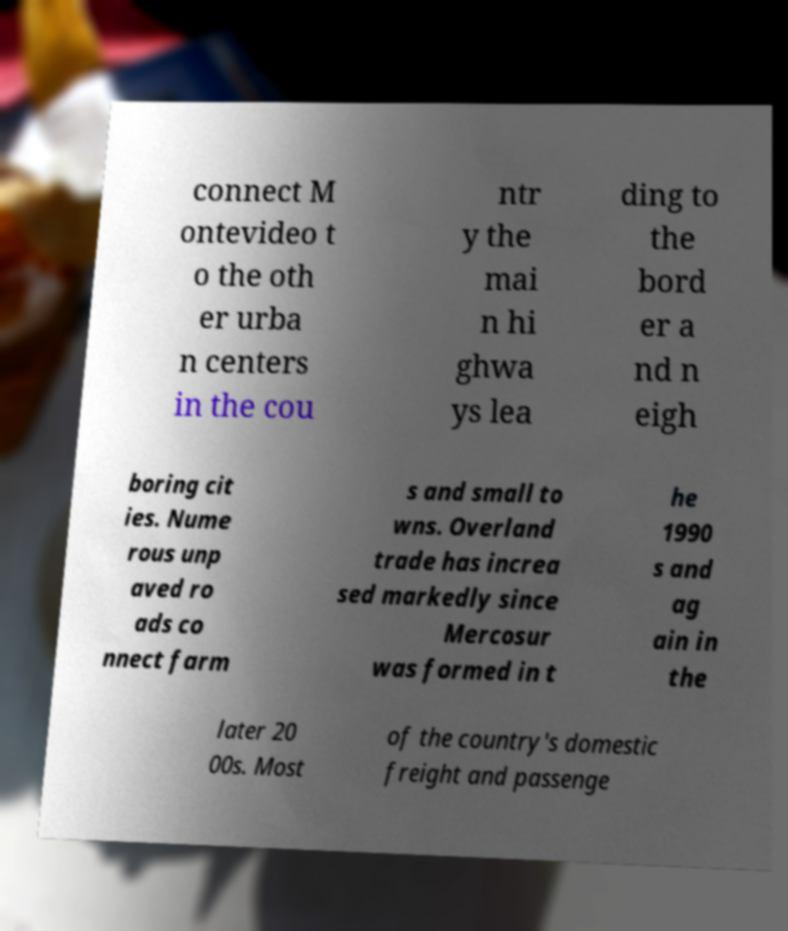Could you assist in decoding the text presented in this image and type it out clearly? connect M ontevideo t o the oth er urba n centers in the cou ntr y the mai n hi ghwa ys lea ding to the bord er a nd n eigh boring cit ies. Nume rous unp aved ro ads co nnect farm s and small to wns. Overland trade has increa sed markedly since Mercosur was formed in t he 1990 s and ag ain in the later 20 00s. Most of the country's domestic freight and passenge 